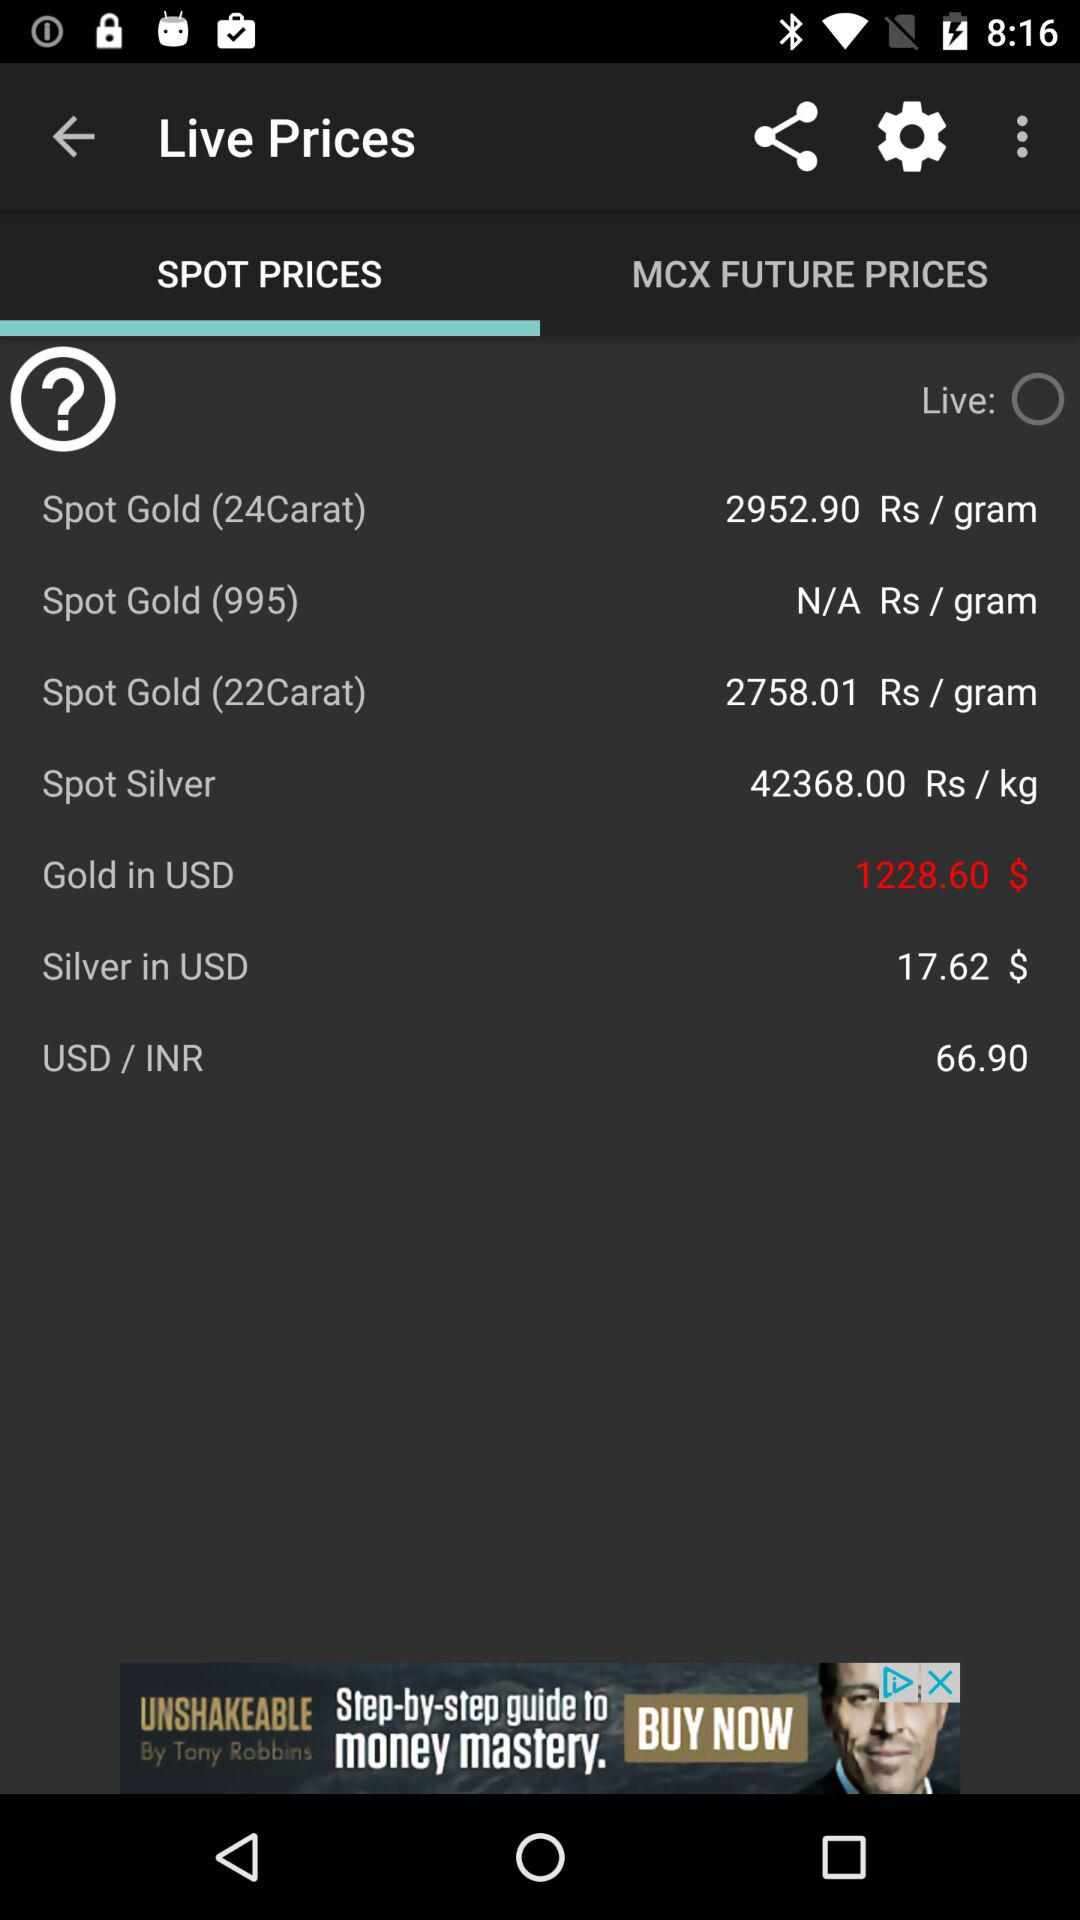What is the spot price of "Silver" in USD? The spot price of "Silver" in USD is $17.62. 